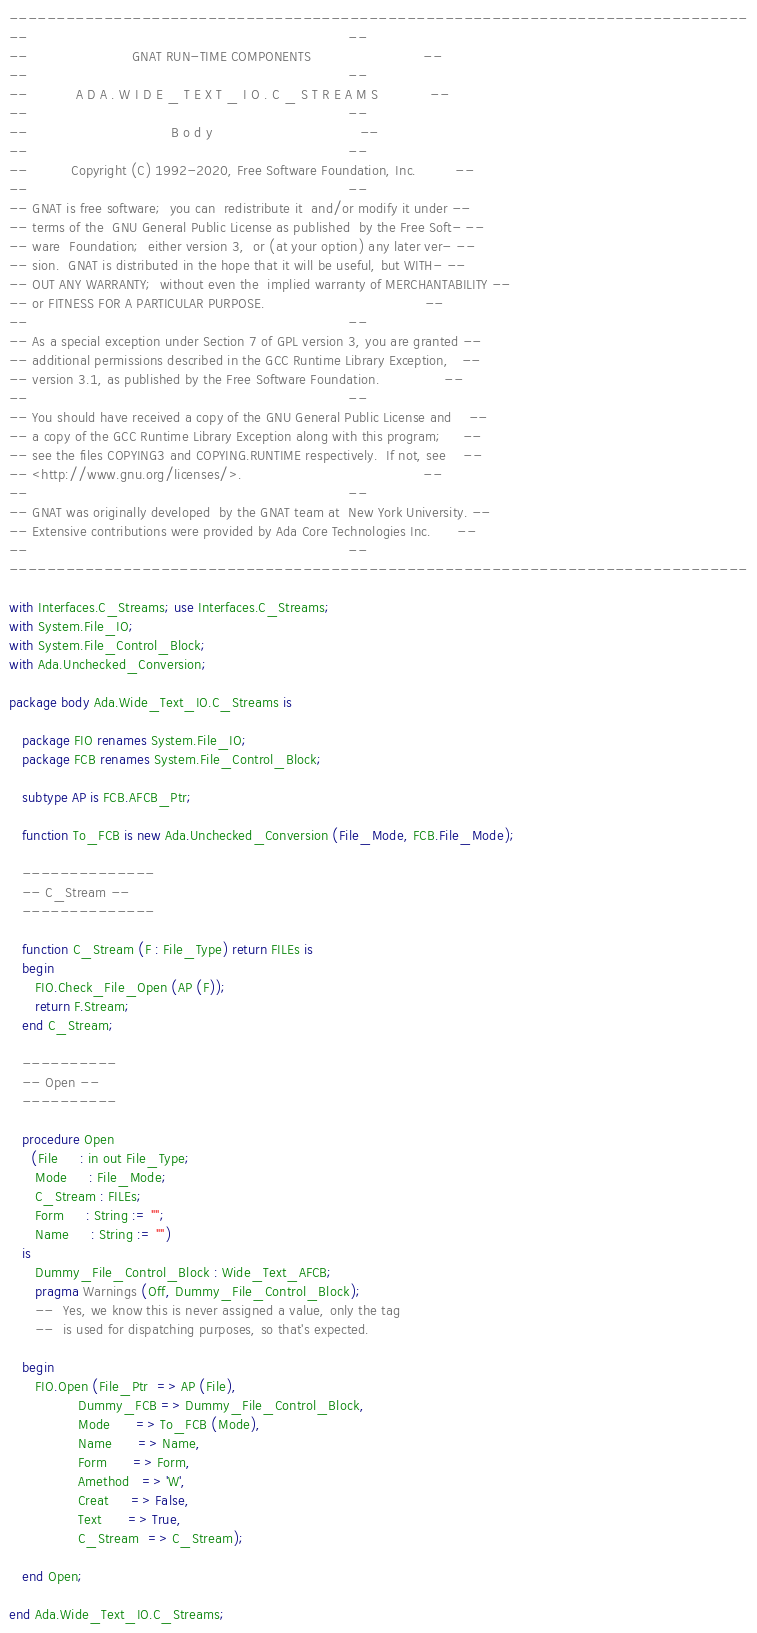Convert code to text. <code><loc_0><loc_0><loc_500><loc_500><_Ada_>------------------------------------------------------------------------------
--                                                                          --
--                        GNAT RUN-TIME COMPONENTS                          --
--                                                                          --
--           A D A . W I D E _ T E X T _ I O . C _ S T R E A M S            --
--                                                                          --
--                                 B o d y                                  --
--                                                                          --
--          Copyright (C) 1992-2020, Free Software Foundation, Inc.         --
--                                                                          --
-- GNAT is free software;  you can  redistribute it  and/or modify it under --
-- terms of the  GNU General Public License as published  by the Free Soft- --
-- ware  Foundation;  either version 3,  or (at your option) any later ver- --
-- sion.  GNAT is distributed in the hope that it will be useful, but WITH- --
-- OUT ANY WARRANTY;  without even the  implied warranty of MERCHANTABILITY --
-- or FITNESS FOR A PARTICULAR PURPOSE.                                     --
--                                                                          --
-- As a special exception under Section 7 of GPL version 3, you are granted --
-- additional permissions described in the GCC Runtime Library Exception,   --
-- version 3.1, as published by the Free Software Foundation.               --
--                                                                          --
-- You should have received a copy of the GNU General Public License and    --
-- a copy of the GCC Runtime Library Exception along with this program;     --
-- see the files COPYING3 and COPYING.RUNTIME respectively.  If not, see    --
-- <http://www.gnu.org/licenses/>.                                          --
--                                                                          --
-- GNAT was originally developed  by the GNAT team at  New York University. --
-- Extensive contributions were provided by Ada Core Technologies Inc.      --
--                                                                          --
------------------------------------------------------------------------------

with Interfaces.C_Streams; use Interfaces.C_Streams;
with System.File_IO;
with System.File_Control_Block;
with Ada.Unchecked_Conversion;

package body Ada.Wide_Text_IO.C_Streams is

   package FIO renames System.File_IO;
   package FCB renames System.File_Control_Block;

   subtype AP is FCB.AFCB_Ptr;

   function To_FCB is new Ada.Unchecked_Conversion (File_Mode, FCB.File_Mode);

   --------------
   -- C_Stream --
   --------------

   function C_Stream (F : File_Type) return FILEs is
   begin
      FIO.Check_File_Open (AP (F));
      return F.Stream;
   end C_Stream;

   ----------
   -- Open --
   ----------

   procedure Open
     (File     : in out File_Type;
      Mode     : File_Mode;
      C_Stream : FILEs;
      Form     : String := "";
      Name     : String := "")
   is
      Dummy_File_Control_Block : Wide_Text_AFCB;
      pragma Warnings (Off, Dummy_File_Control_Block);
      --  Yes, we know this is never assigned a value, only the tag
      --  is used for dispatching purposes, so that's expected.

   begin
      FIO.Open (File_Ptr  => AP (File),
                Dummy_FCB => Dummy_File_Control_Block,
                Mode      => To_FCB (Mode),
                Name      => Name,
                Form      => Form,
                Amethod   => 'W',
                Creat     => False,
                Text      => True,
                C_Stream  => C_Stream);

   end Open;

end Ada.Wide_Text_IO.C_Streams;
</code> 